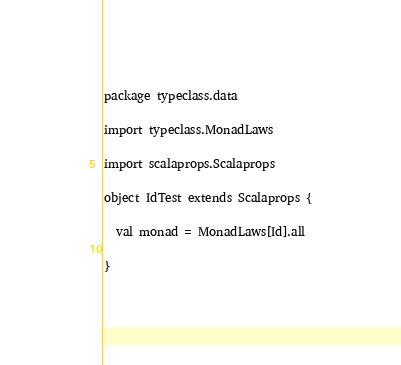<code> <loc_0><loc_0><loc_500><loc_500><_Scala_>package typeclass.data

import typeclass.MonadLaws

import scalaprops.Scalaprops

object IdTest extends Scalaprops {

  val monad = MonadLaws[Id].all

}
</code> 